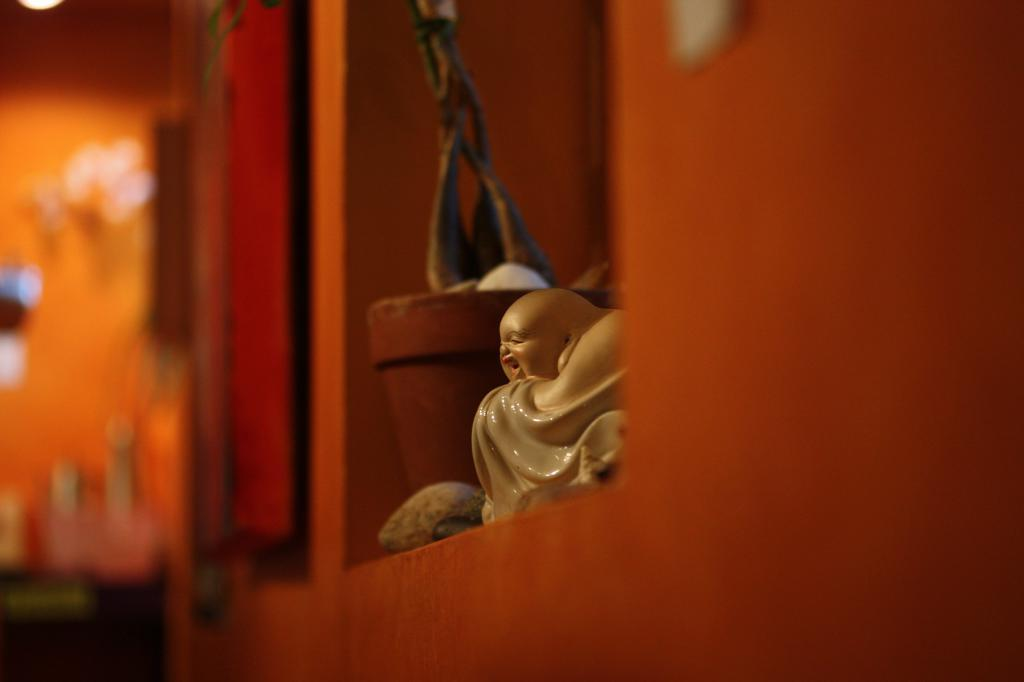What is the main subject of the image? There is a laughing Buddha in the image. What else can be seen in the image besides the laughing Buddha? There is a plant in the image. Where are the laughing Buddha and the plant located? Both the laughing Buddha and the plant are kept on a shelf. What is the color of the wall beside the shelf? The wall beside the shelf is orange. How is the background of the image? The background of the wall is blurred. What type of net is being used to catch the cat in the image? There is no cat or net present in the image. 